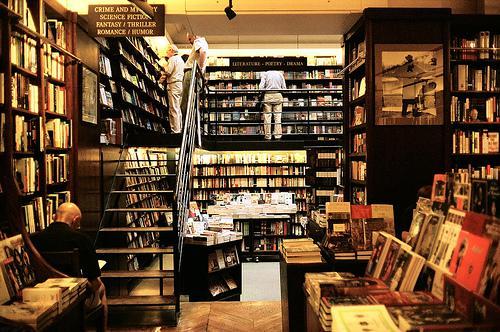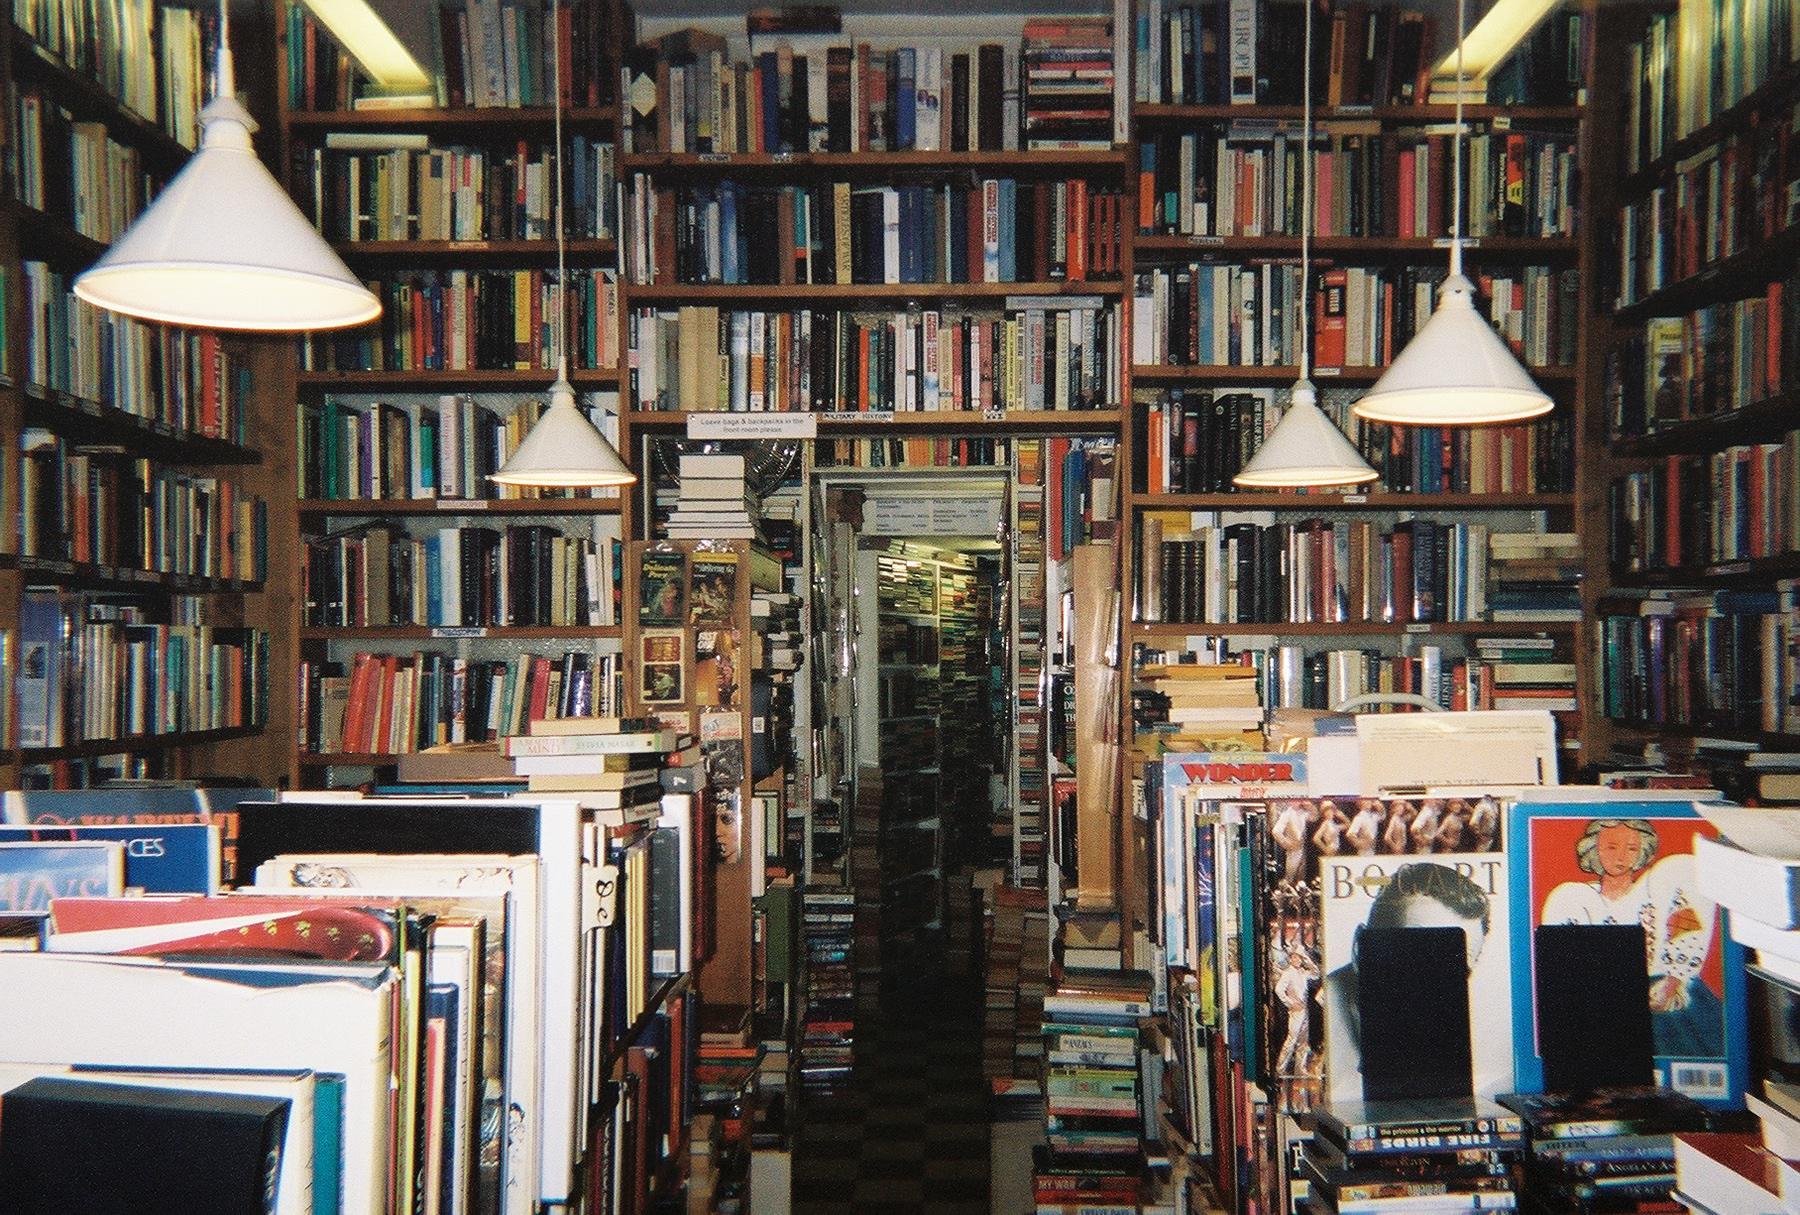The first image is the image on the left, the second image is the image on the right. For the images shown, is this caption "In this book store there is at least one person looking at  books from the shelve." true? Answer yes or no. Yes. The first image is the image on the left, the second image is the image on the right. For the images shown, is this caption "The right image contains an outside view of a storefront." true? Answer yes or no. No. 